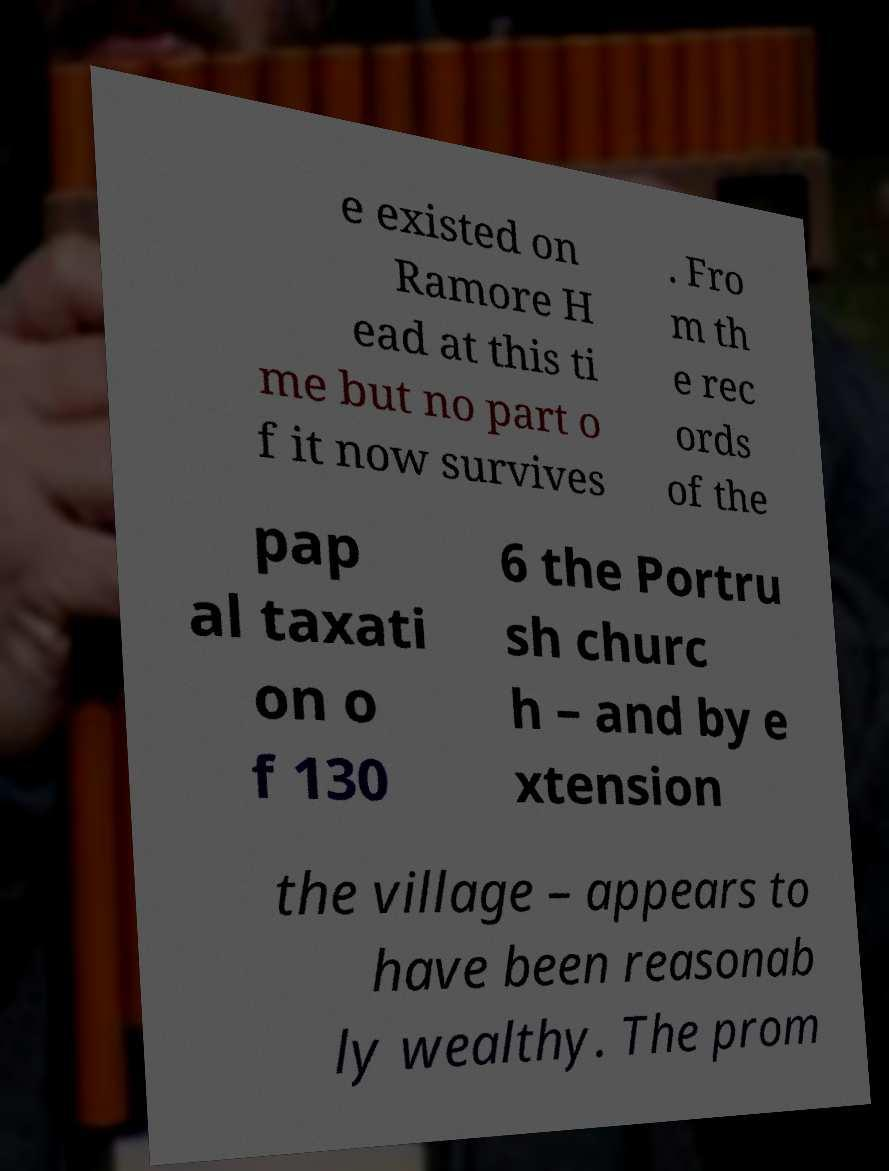Please read and relay the text visible in this image. What does it say? e existed on Ramore H ead at this ti me but no part o f it now survives . Fro m th e rec ords of the pap al taxati on o f 130 6 the Portru sh churc h – and by e xtension the village – appears to have been reasonab ly wealthy. The prom 